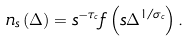<formula> <loc_0><loc_0><loc_500><loc_500>n _ { s } \left ( \Delta \right ) = s ^ { - \tau _ { c } } f \left ( s \Delta ^ { 1 / \sigma _ { c } } \right ) .</formula> 